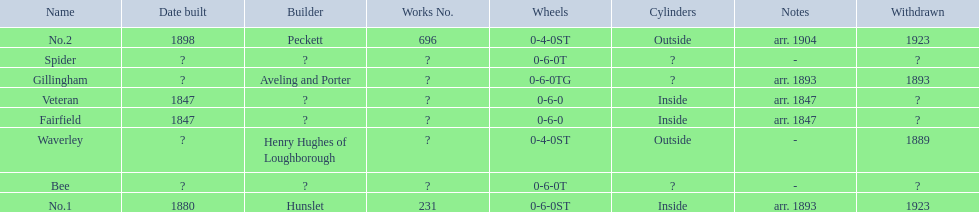Which have known built dates? Veteran, Fairfield, No.1, No.2. What other was built in 1847? Veteran. 